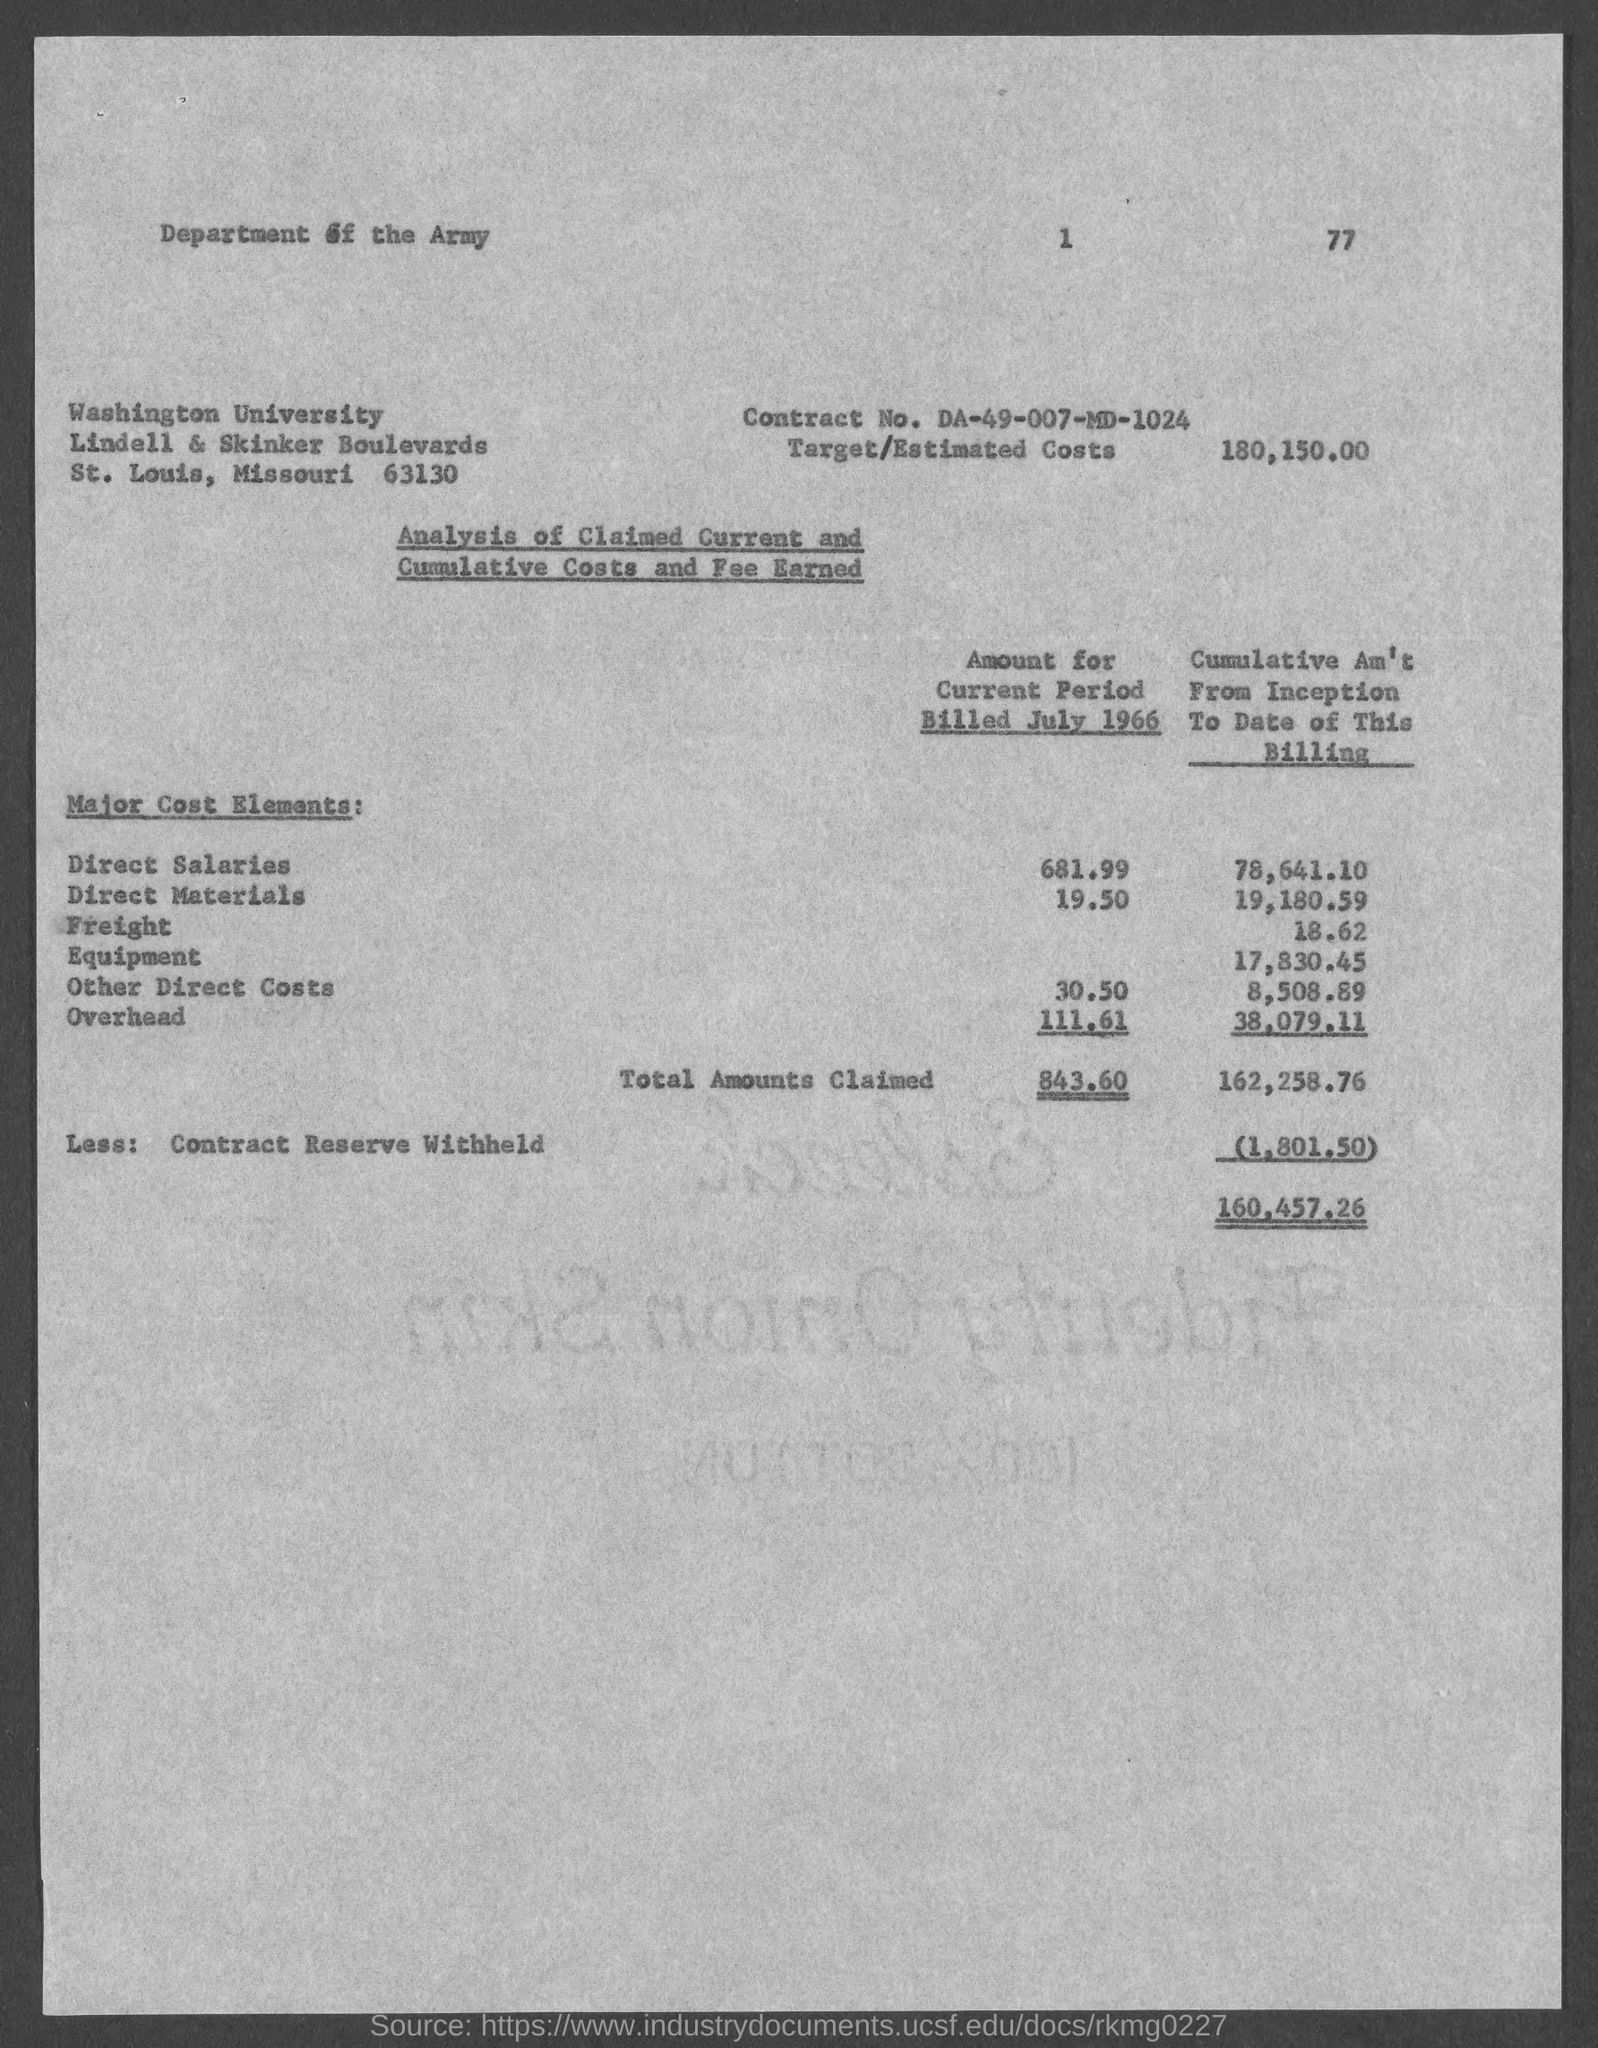What is the contract no.?
Your response must be concise. DA-49-007-MD-1024. What is the street address of washington university ?
Your answer should be compact. Lindell & skinker boulevards. In which county is washington university  located?
Your answer should be very brief. St. louis. What is the target/estimated costs ?
Ensure brevity in your answer.  $180,150.00. 